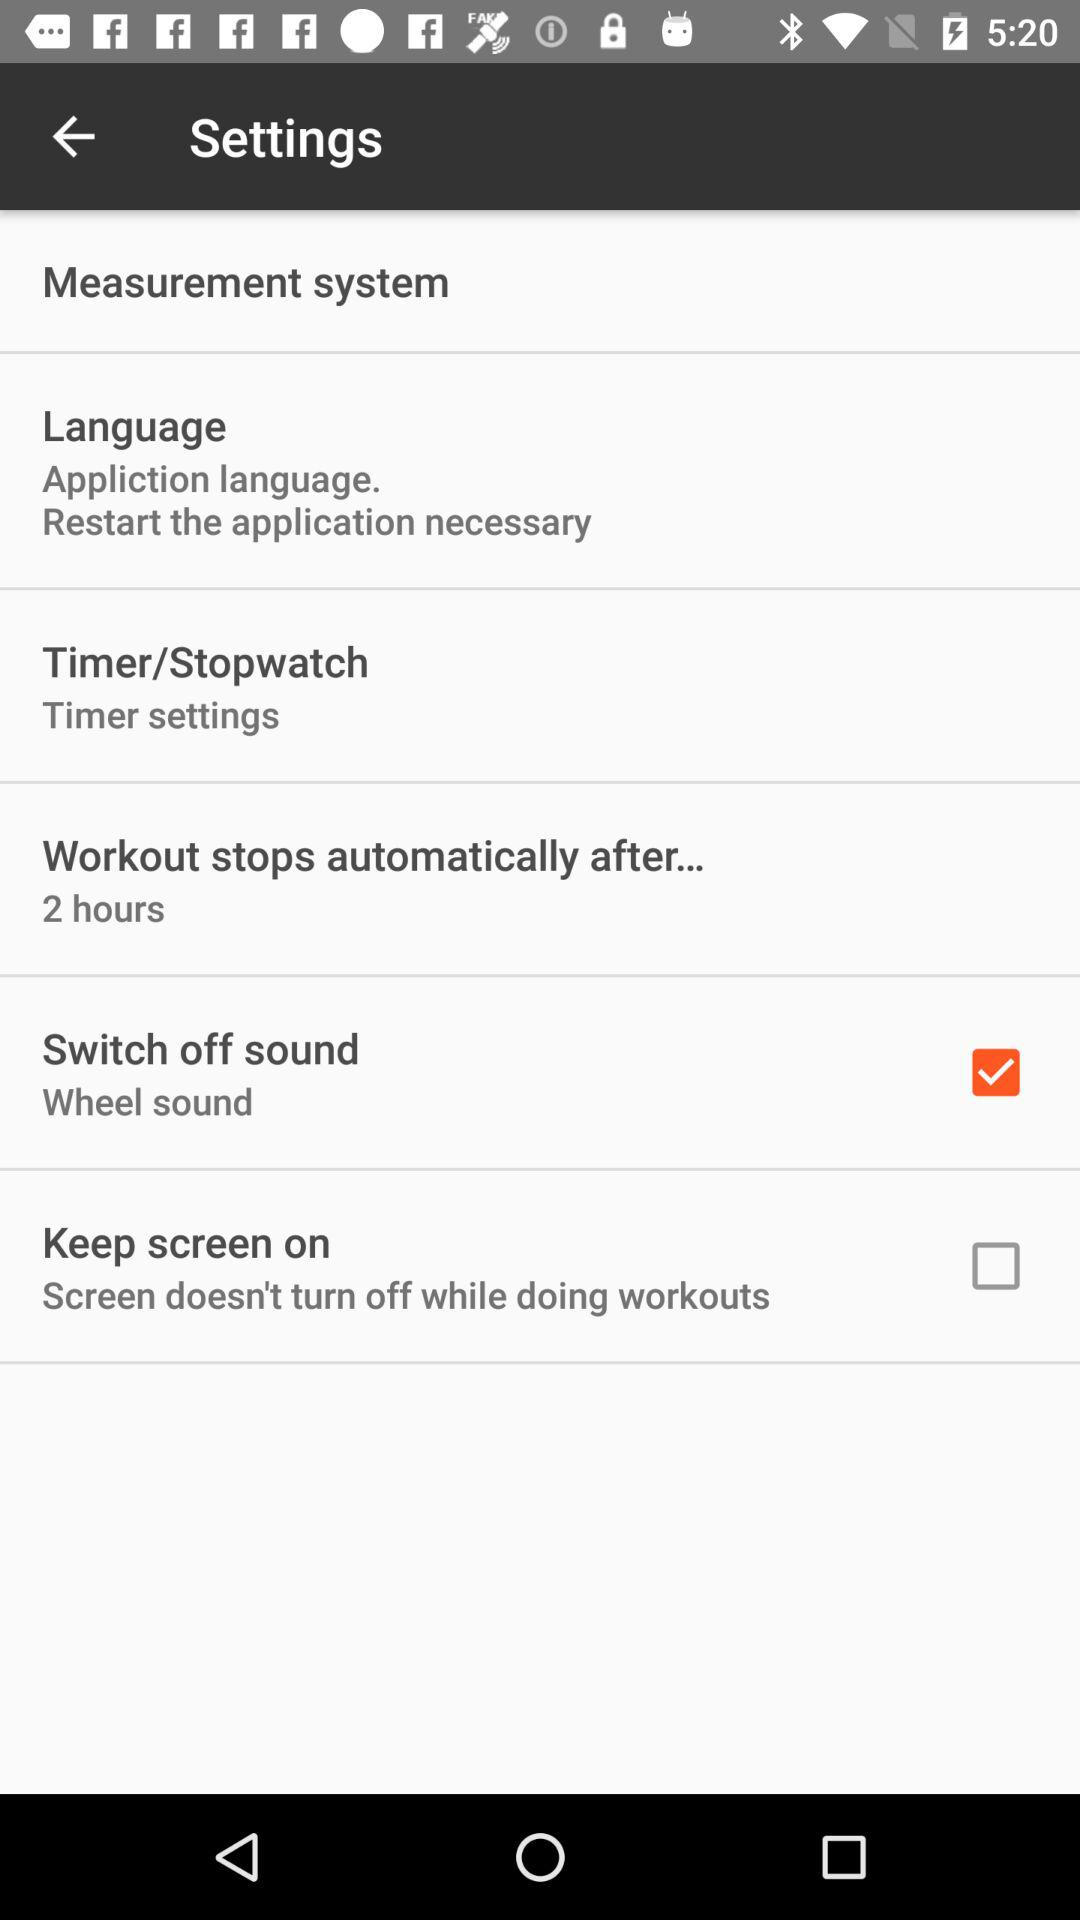Which settings are unchecked? The unchecked setting is "Keep screen on". 